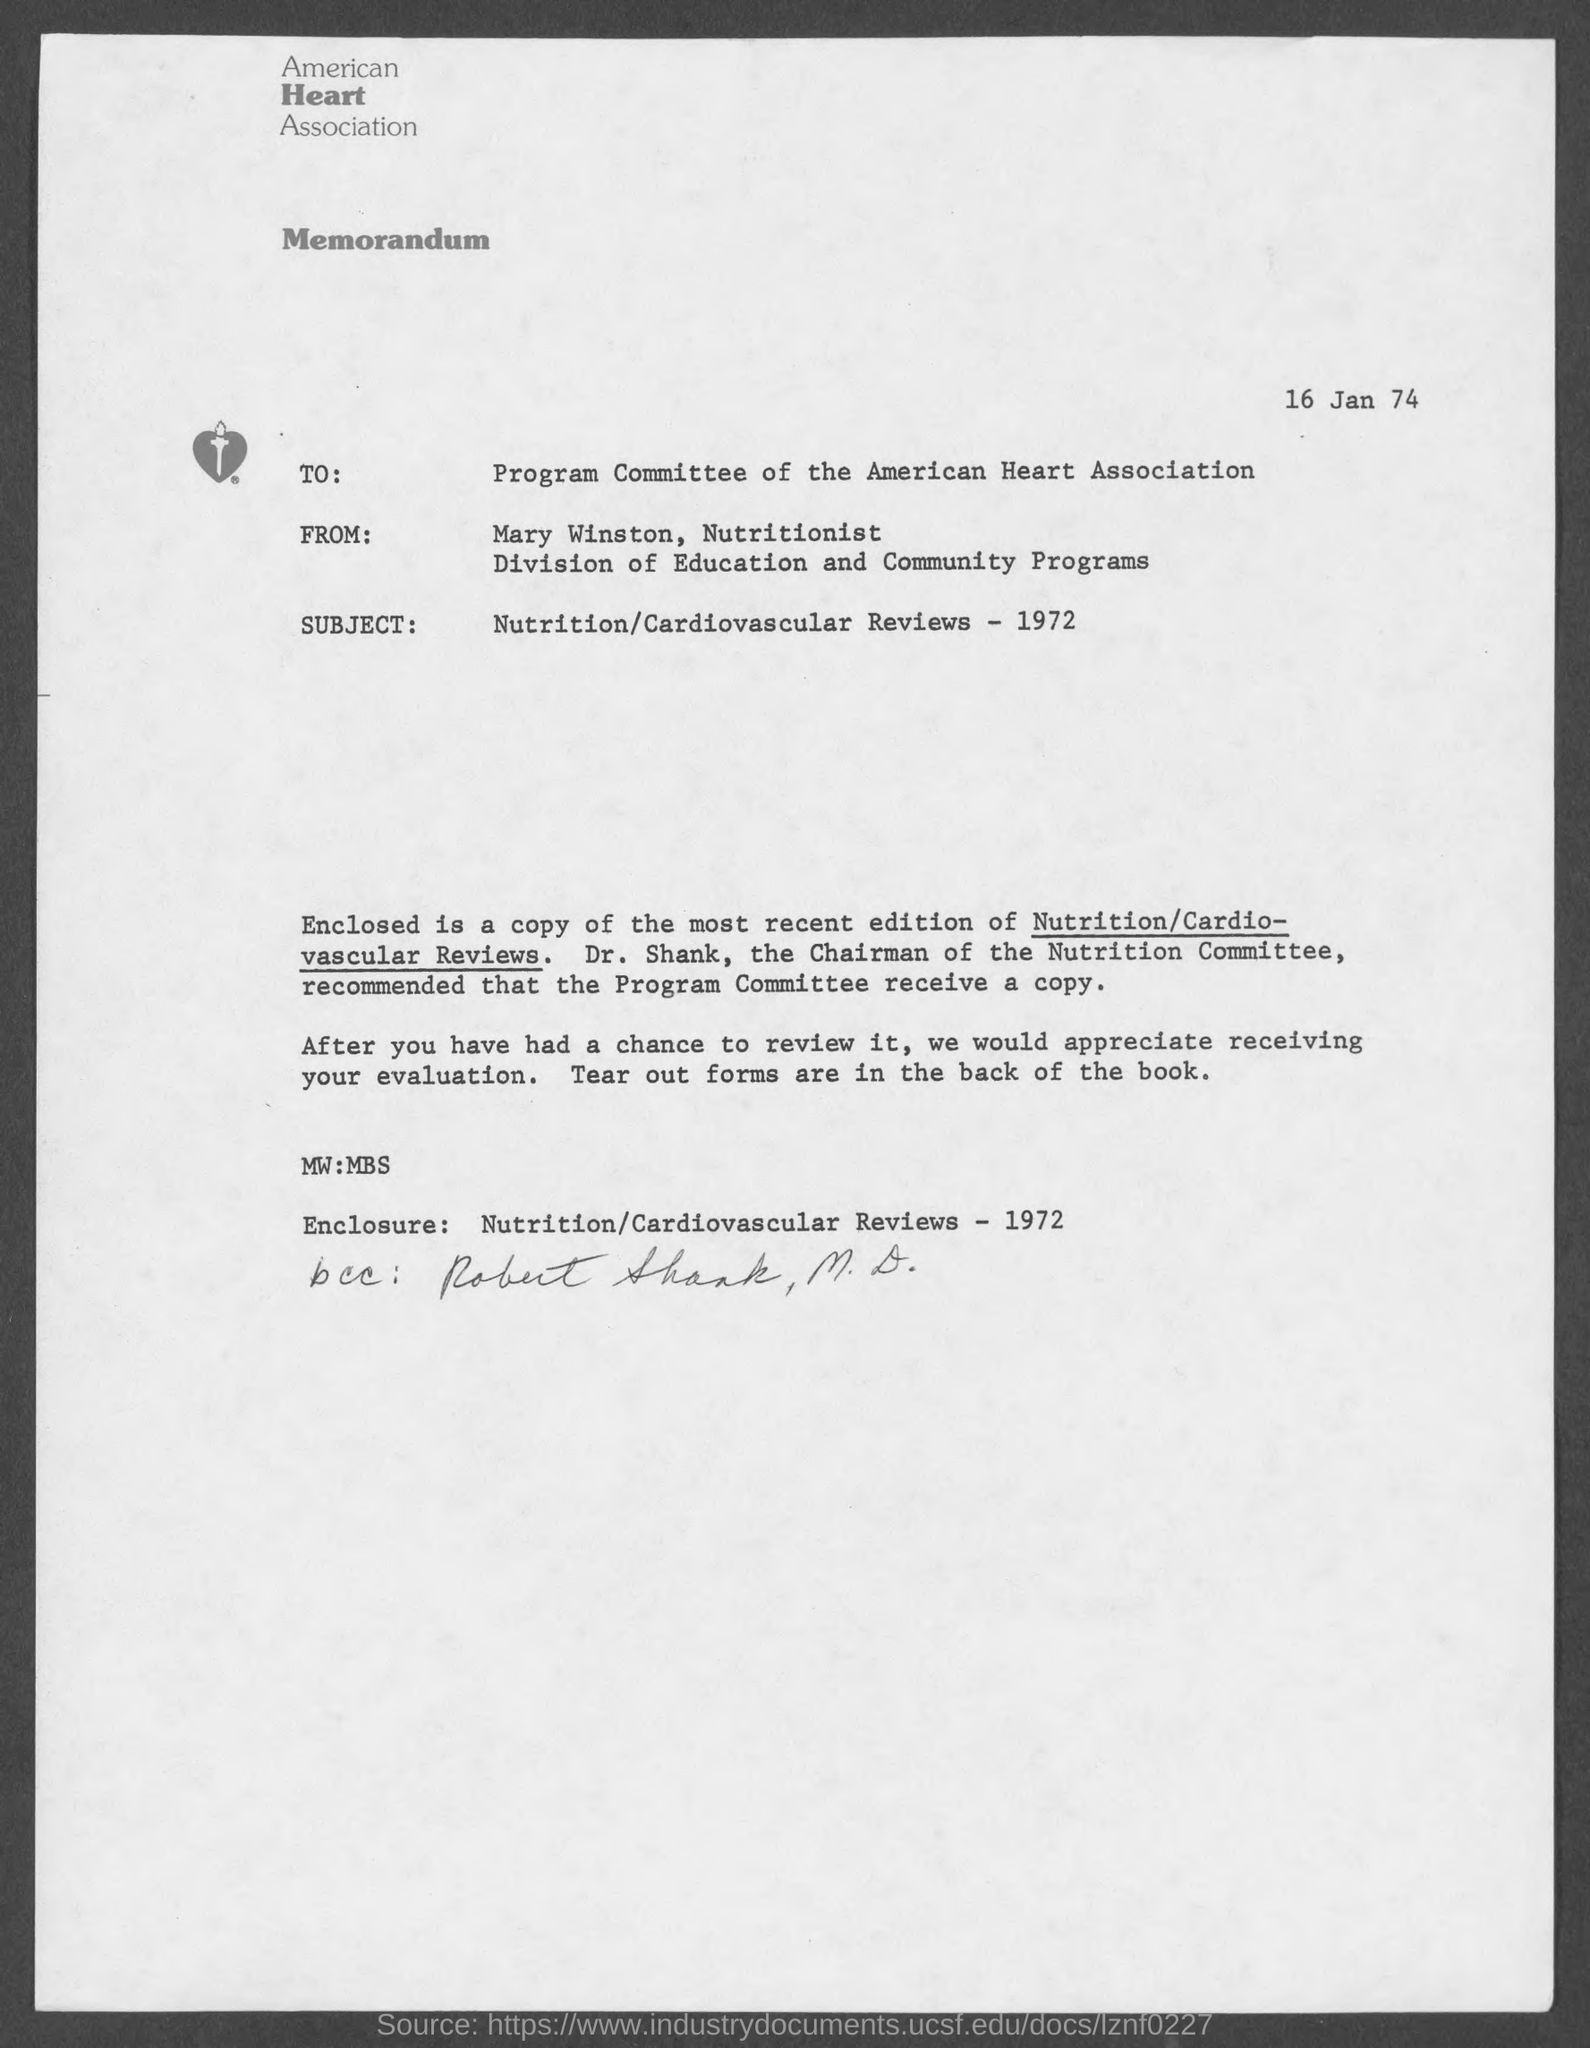Identify some key points in this picture. Mary Winston holds the position of nutritionist. The memorandum is dated 16 January 1974. The author of the memorandum is Mary Winston. The name of the American Heart Association is the American Heart Association. 